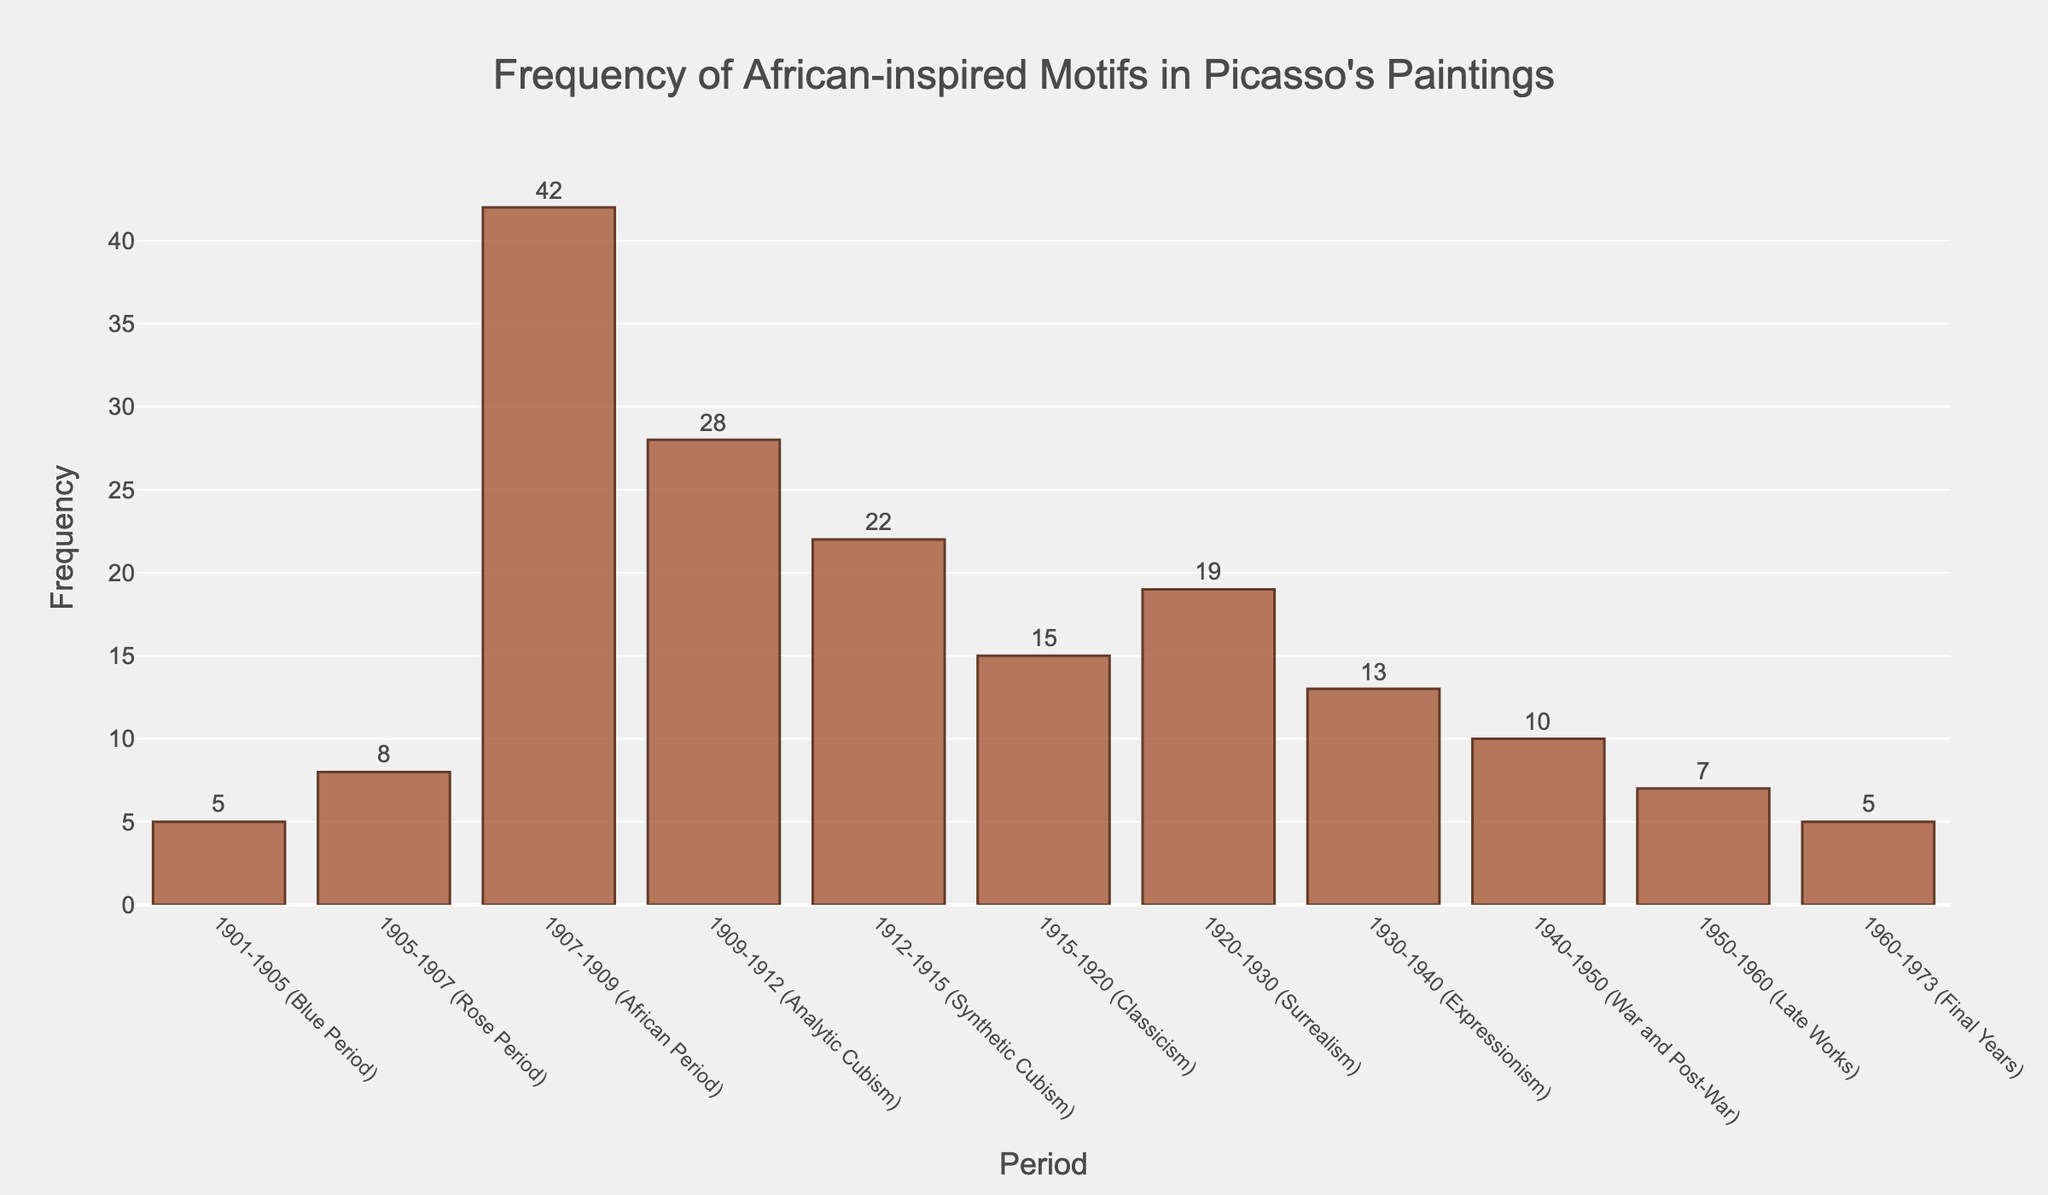What is the period with the highest frequency of African-inspired motifs in Picasso's paintings? The period with the highest frequency can be identified by looking for the tallest bar in the chart. The "1907-1909 (African Period)" has the highest frequency bar.
Answer: 1907-1909 (African Period) What is the total frequency of African-inspired motifs from 1901-1905 (Blue Period) to 1907-1909 (African Period)? Sum the frequencies from 1901-1905 (5), 1905-1907 (8), and 1907-1909 (42). 5 + 8 + 42 = 55
Answer: 55 Which period has a higher frequency of African-inspired motifs: 1915-1920 (Classicism) or 1930-1940 (Expressionism)? Compare the heights of the bars for the two periods. 1915-1920 has a frequency of 15 and 1930-1940 has a frequency of 13.
Answer: 1915-1920 (Classicism) What is the average frequency of African-inspired motifs in Picasso's work from 1909-1915? Add the frequencies from 1909-1912 (28) and 1912-1915 (22), then divide by the number of periods. (28 + 22) / 2 = 25
Answer: 25 How many periods have a frequency of African-inspired motifs greater than 20? Count the bars with a frequency higher than 20. These periods are 1907-1909 (42), 1909-1912 (28), and 1912-1915 (22).
Answer: 3 Which period marks the start of a significant increase in the frequency of African-inspired motifs in Picasso's paintings? Look for the first major jump in frequency. This happens between 1905-1907 (8) and 1907-1909 (42).
Answer: 1907-1909 (African Period) What is the total frequency of African-inspired motifs from 1915-1973? Sum the frequencies from each relevant period: 1915-1920 (15), 1920-1930 (19), 1930-1940 (13), 1940-1950 (10), 1950-1960 (7), 1960-1973 (5). 15 + 19 + 13 + 10 + 7 + 5 = 69
Answer: 69 Which period experienced the greatest decline in frequency of African-inspired motifs compared to the previous period? Calculate the difference in frequency for each consecutive period and find the largest reduction. The greatest decline is from 1907-1909 (42) to 1909-1912 (28), a decrease of 14.
Answer: 1909-1912 (Analytic Cubism) Does the frequency of African-inspired motifs remain above 10 after the 1912-1915 (Synthetic Cubism) period? Check the heights of the bars for subsequent periods. Frequencies are 15, 19, 13, 10, 7, 5. Some periods are above 10, not all.
Answer: No What is the difference in the number of motifs between the African Period and the Final Years? Subtract the frequency of the Final Years period from that of the African Period. 42 - 5 = 37
Answer: 37 